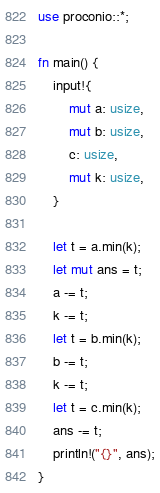Convert code to text. <code><loc_0><loc_0><loc_500><loc_500><_Rust_>use proconio::*;

fn main() {
    input!{
        mut a: usize,
        mut b: usize,
        c: usize,
        mut k: usize,
    }

    let t = a.min(k);
    let mut ans = t;
    a -= t;
    k -= t;
    let t = b.min(k);
    b -= t;
    k -= t;
    let t = c.min(k);
    ans -= t;
    println!("{}", ans);
}
</code> 